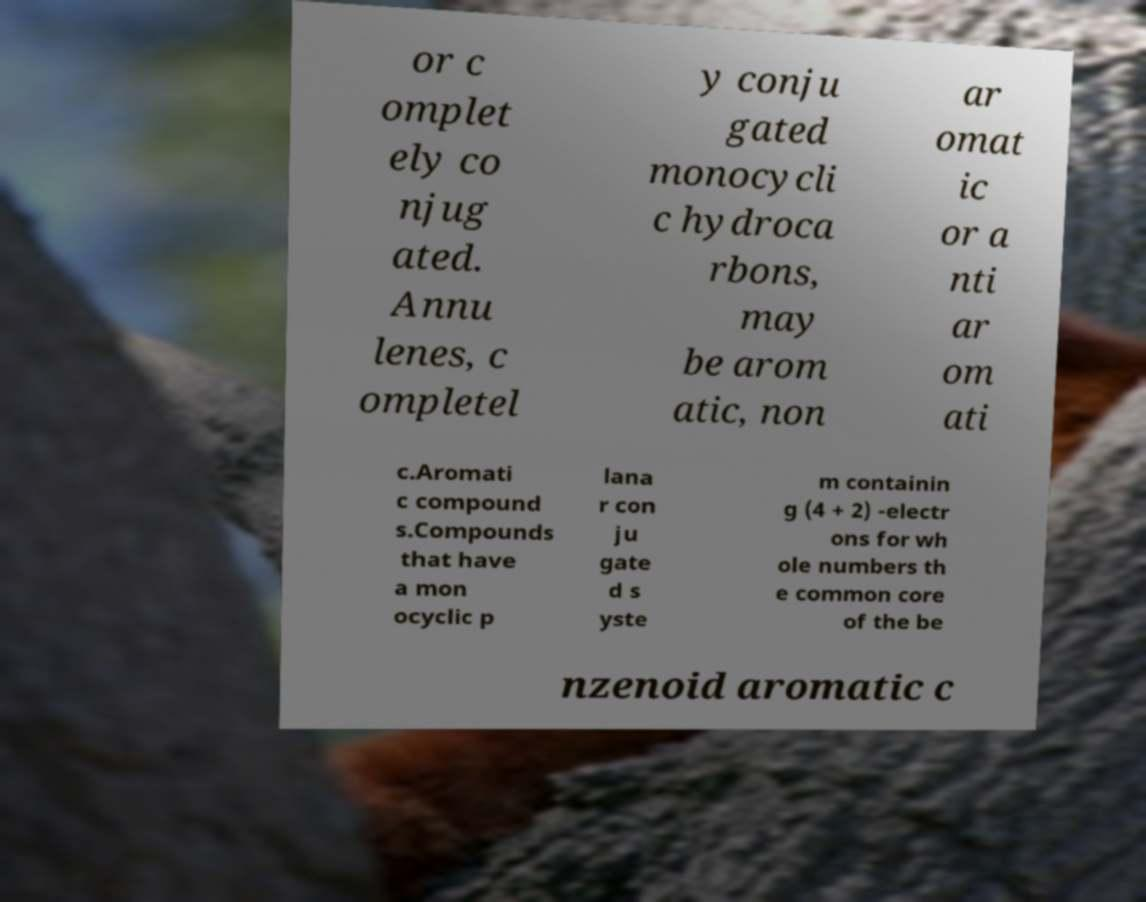Can you accurately transcribe the text from the provided image for me? or c omplet ely co njug ated. Annu lenes, c ompletel y conju gated monocycli c hydroca rbons, may be arom atic, non ar omat ic or a nti ar om ati c.Aromati c compound s.Compounds that have a mon ocyclic p lana r con ju gate d s yste m containin g (4 + 2) -electr ons for wh ole numbers th e common core of the be nzenoid aromatic c 